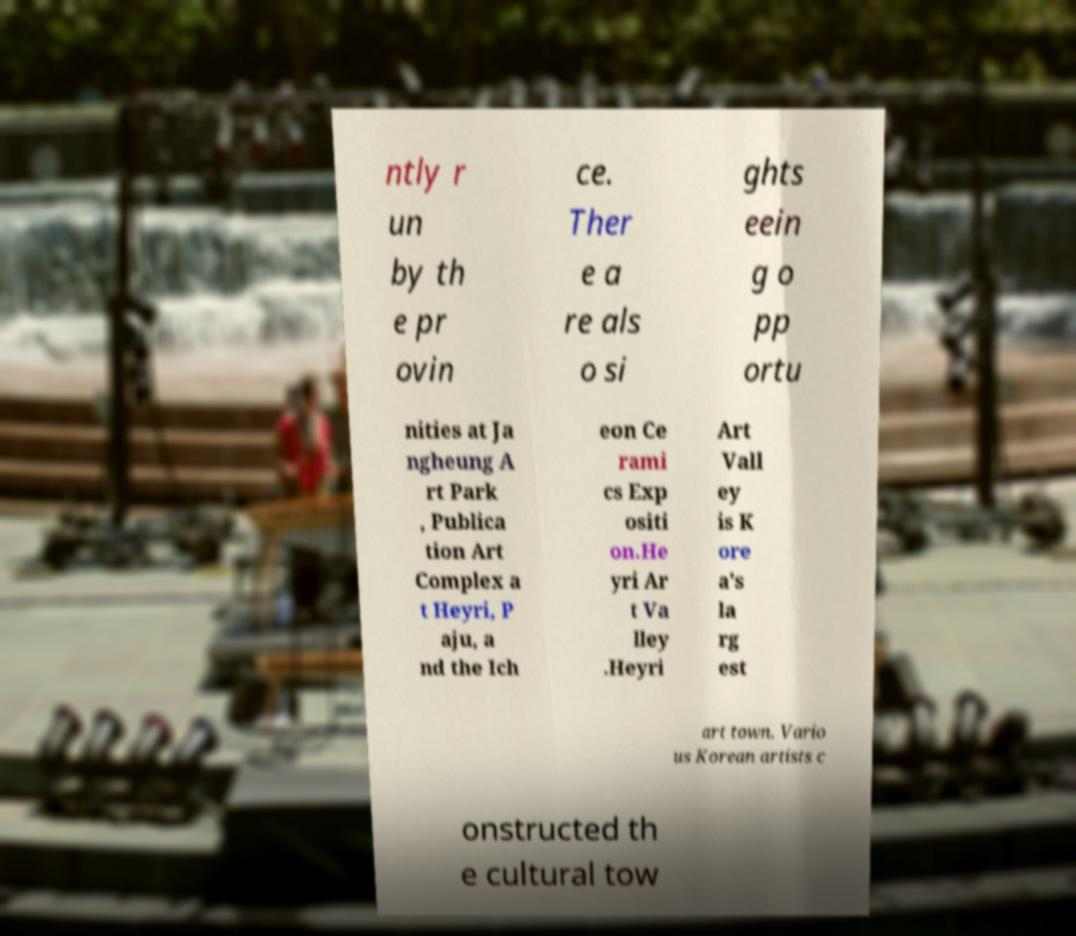Can you accurately transcribe the text from the provided image for me? ntly r un by th e pr ovin ce. Ther e a re als o si ghts eein g o pp ortu nities at Ja ngheung A rt Park , Publica tion Art Complex a t Heyri, P aju, a nd the Ich eon Ce rami cs Exp ositi on.He yri Ar t Va lley .Heyri Art Vall ey is K ore a's la rg est art town. Vario us Korean artists c onstructed th e cultural tow 